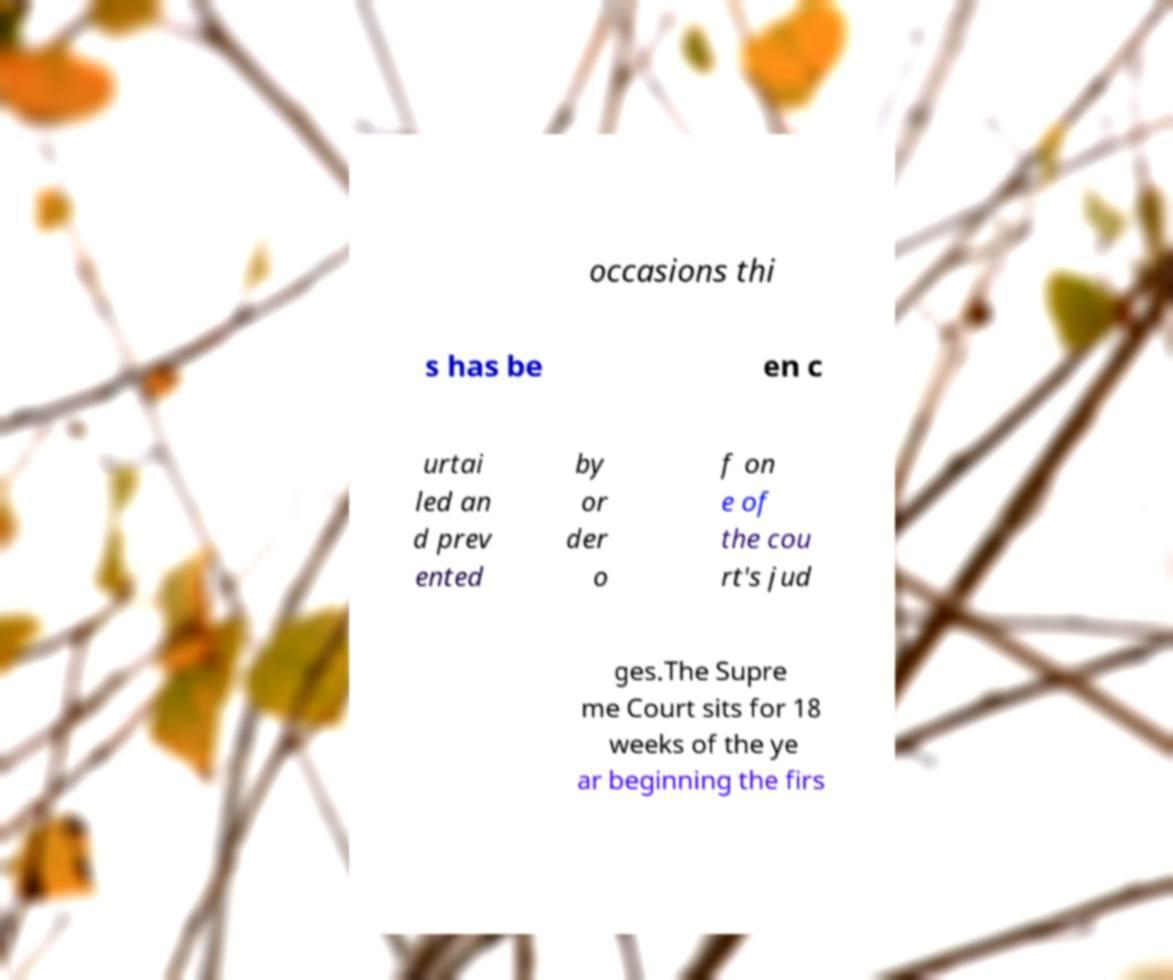Please read and relay the text visible in this image. What does it say? occasions thi s has be en c urtai led an d prev ented by or der o f on e of the cou rt's jud ges.The Supre me Court sits for 18 weeks of the ye ar beginning the firs 